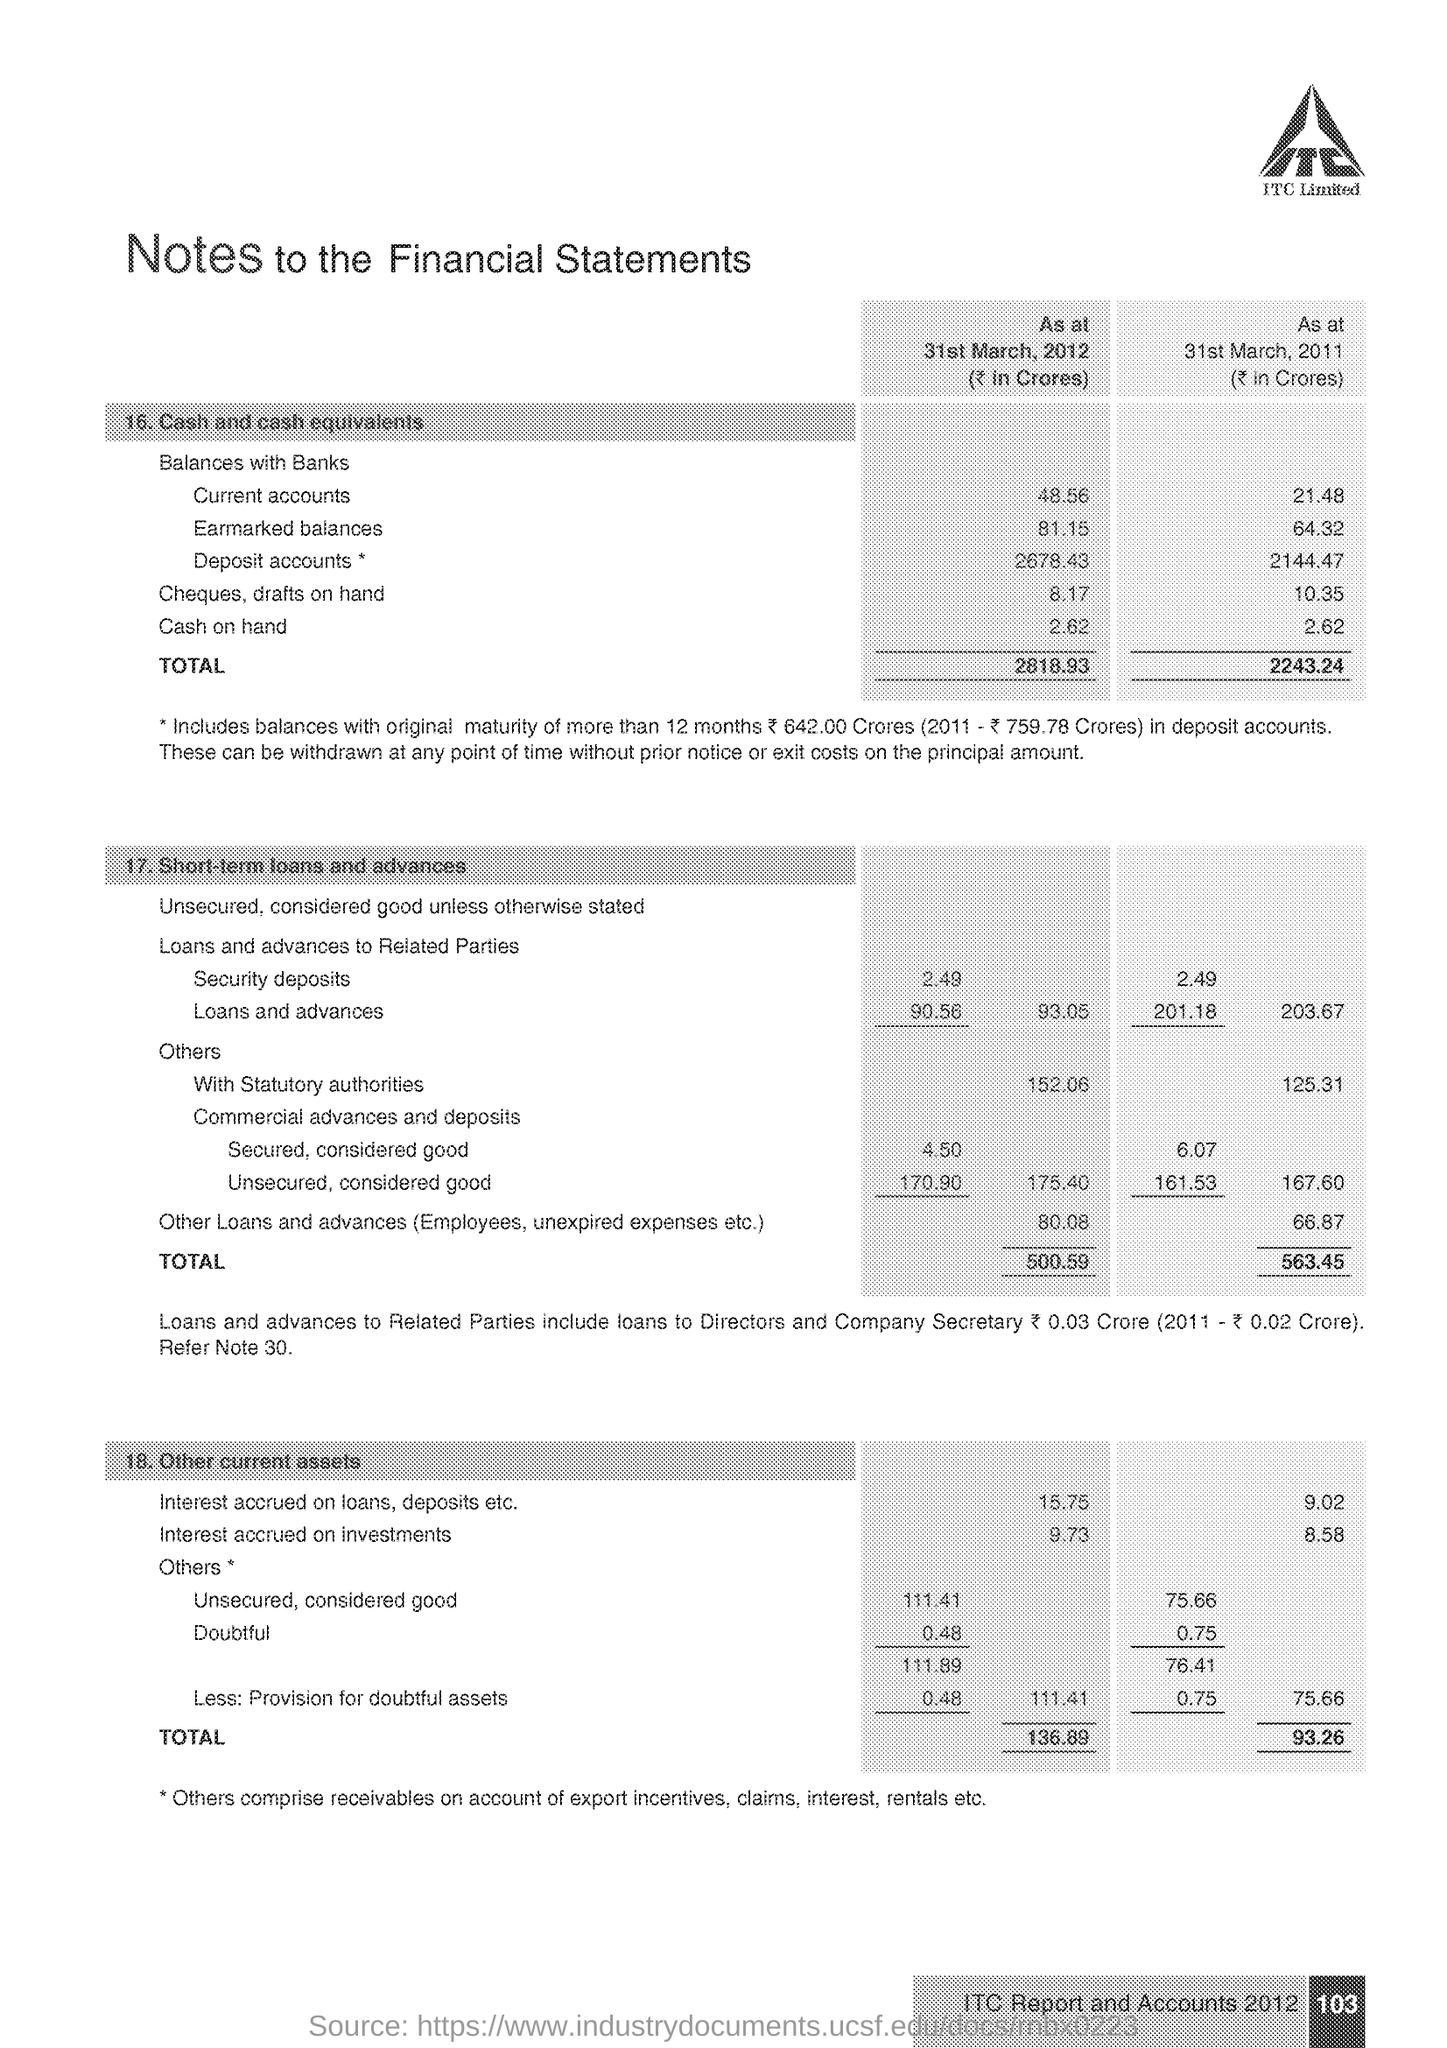Give some essential details in this illustration. The title of the document is Notes to the Financial Statements. The company name is ITC. The amount of cash on hand in 2012 was 2.62. 